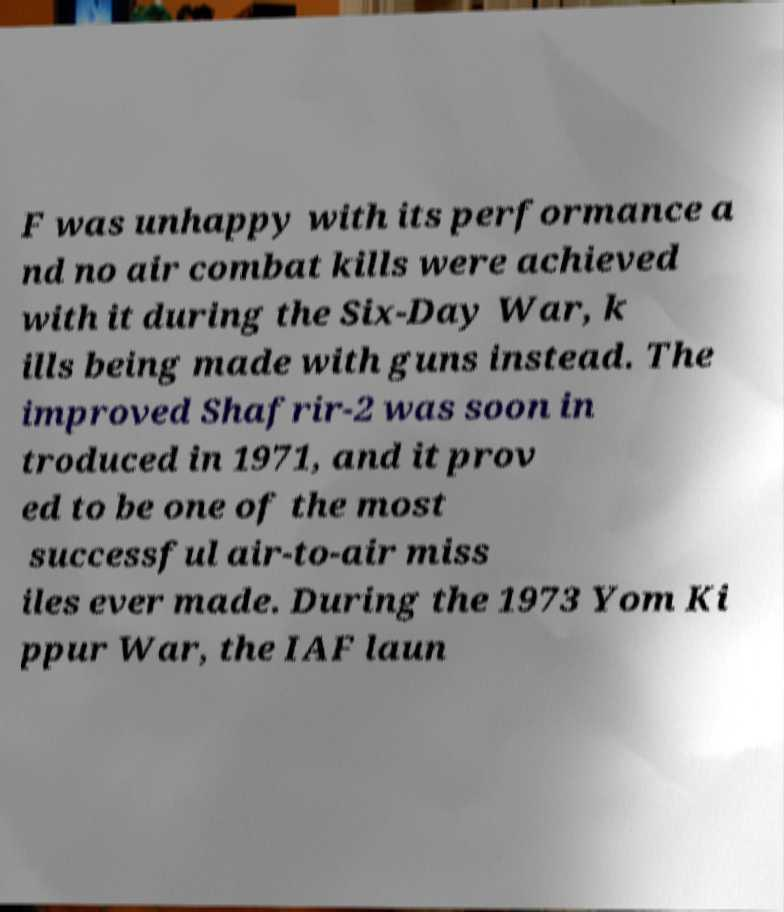Please read and relay the text visible in this image. What does it say? F was unhappy with its performance a nd no air combat kills were achieved with it during the Six-Day War, k ills being made with guns instead. The improved Shafrir-2 was soon in troduced in 1971, and it prov ed to be one of the most successful air-to-air miss iles ever made. During the 1973 Yom Ki ppur War, the IAF laun 